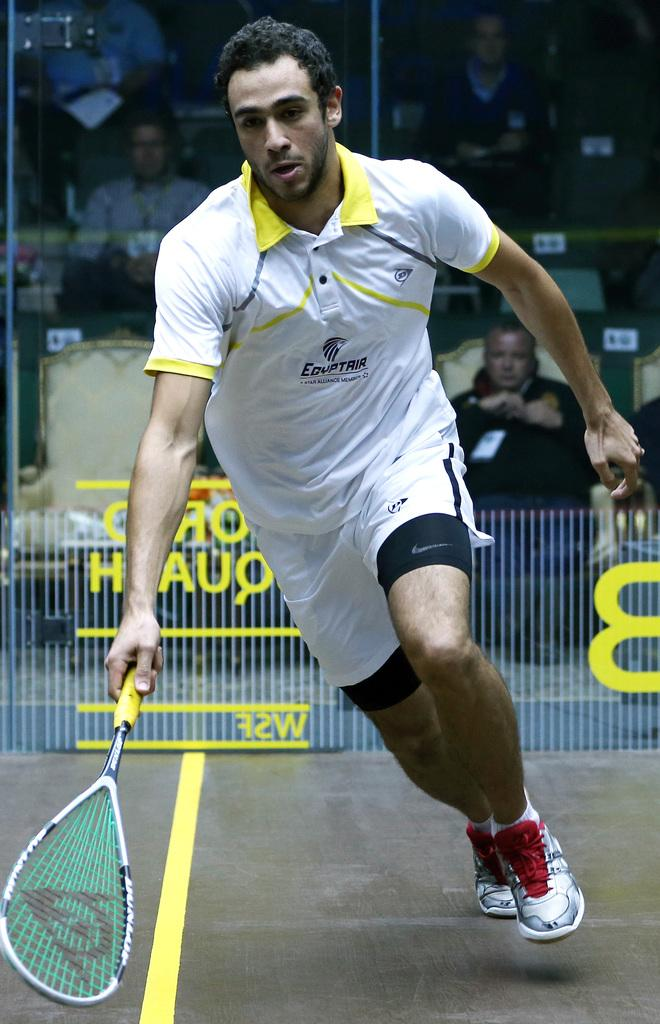Who is present in the image? There is a man in the image. What is the man doing in the image? The man is standing in the image. What object is the man holding in his hand? The man is holding a tennis racket in his hand. What can be seen in the background of the image? There are people sitting in the background of the image. What type of wrench is the man using to fix the impulse in the image? There is no wrench or impulse present in the image. The man is holding a tennis racket, not a wrench, and there is no mention of an impulse in the image. 